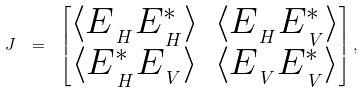Convert formula to latex. <formula><loc_0><loc_0><loc_500><loc_500>J \ = \ \begin{bmatrix} \langle E _ { \, _ { H } } E ^ { * } _ { \, _ { H } } \rangle & \langle E _ { \, _ { H } } E ^ { * } _ { \, _ { V } } \rangle \\ \langle E ^ { * } _ { \, _ { H } } E _ { \, _ { V } } \rangle & \langle E _ { \, _ { V } } E ^ { * } _ { \, _ { V } } \rangle \end{bmatrix} , \,</formula> 